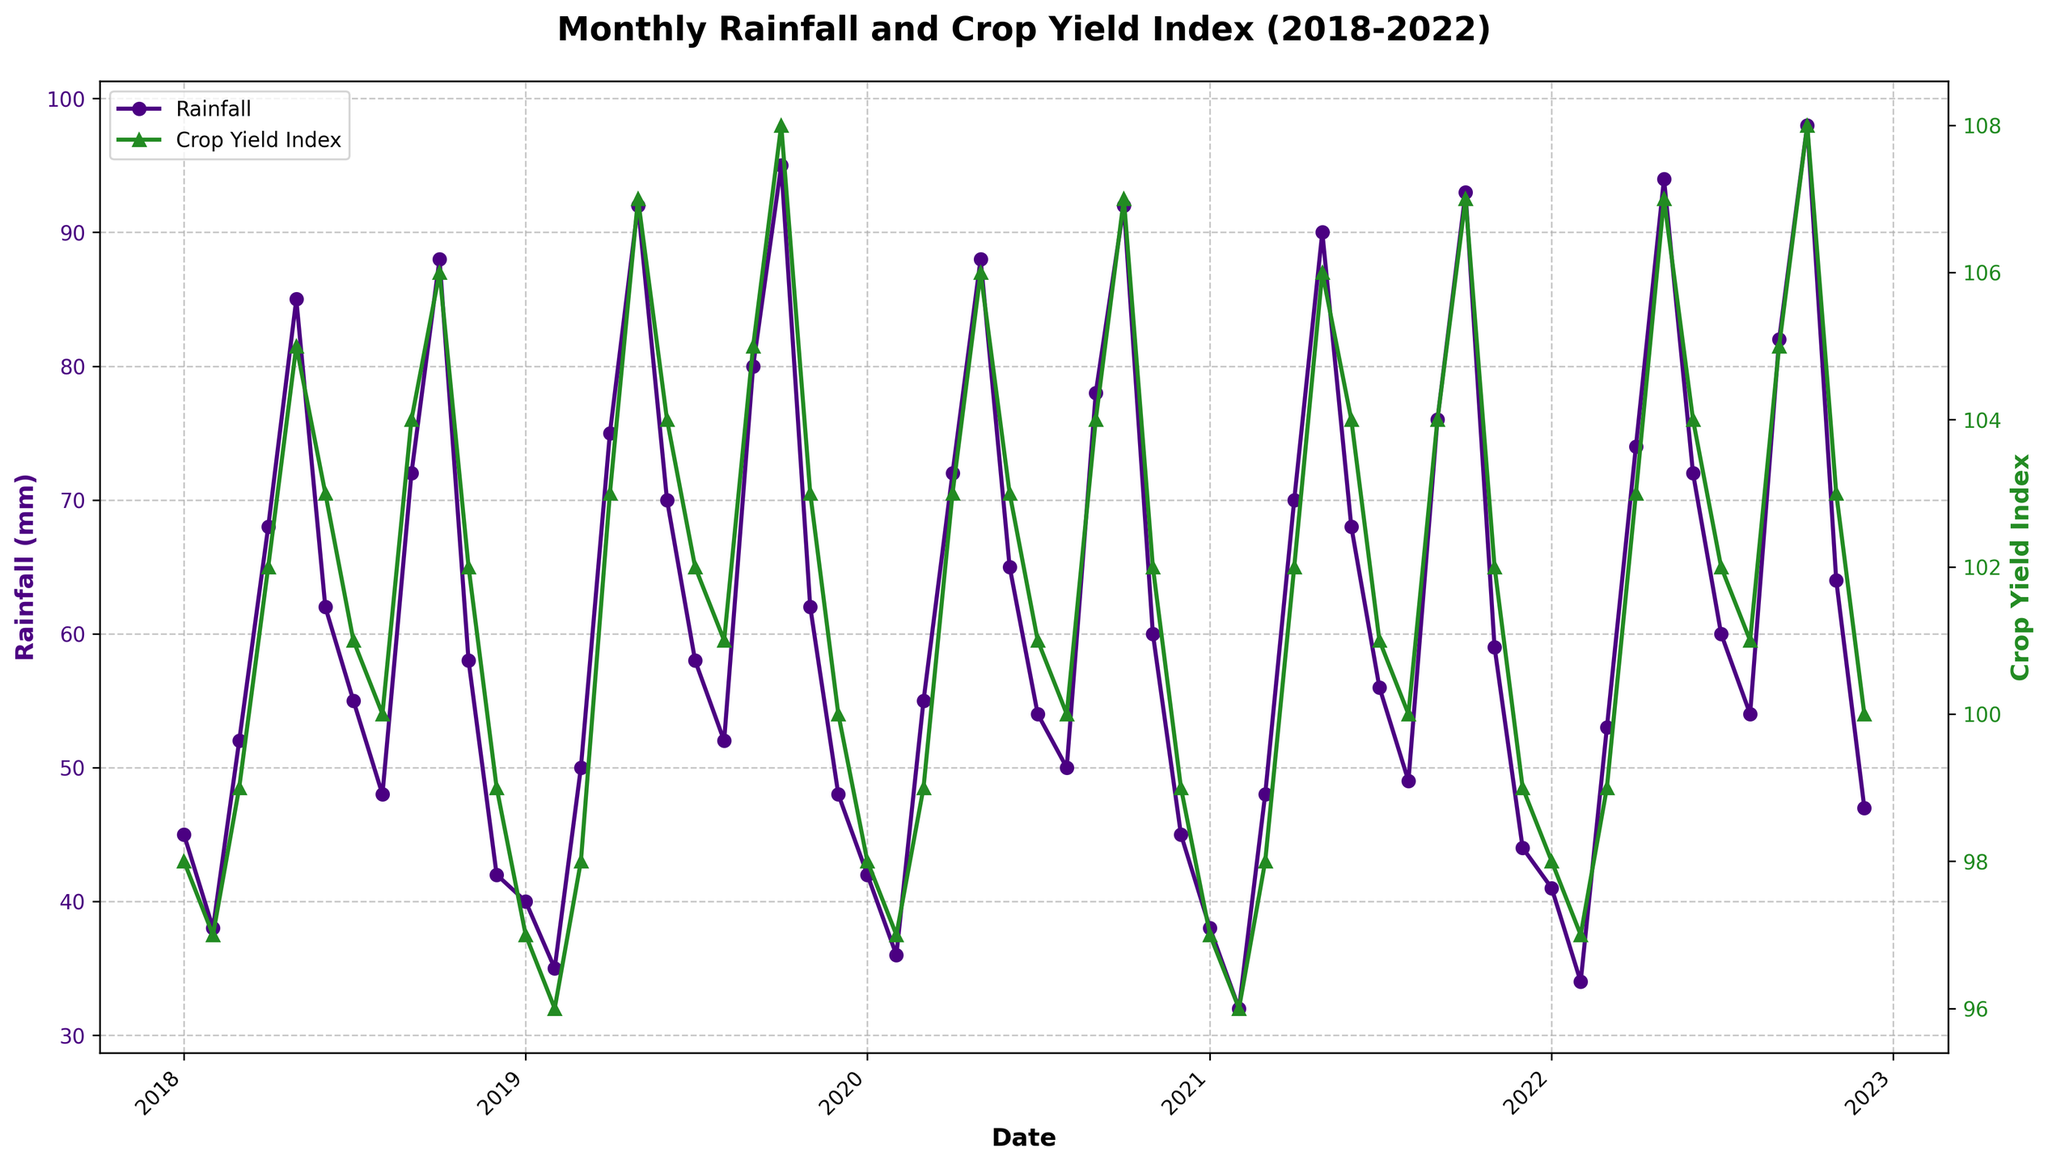What was the total rainfall in 2018? To find the total rainfall in 2018, add up the monthly rainfall values for each month in 2018: 45 + 38 + 52 + 68 + 85 + 62 + 55 + 48 + 72 + 88 + 58 + 42 = 713
Answer: 713 mm Which year had the highest Crop Yield Index in the month of October? Look at the Crop Yield Index values for October in each year and find the highest value: Oct 2018 (106), Oct 2019 (108), Oct 2020 (107), Oct 2021 (107), Oct 2022 (108). The highest value occurs in both 2019 and 2022.
Answer: 2019 and 2022 Did rainfall generally decrease or increase from January to May between 2018 and 2022? Observe the rainfall trend from January to May for each year. For better understanding, calculate the difference for each year: 
2018: 45 to 85 (increase), 
2019: 40 to 92 (increase), 
2020: 42 to 88 (increase), 
2021: 38 to 90 (increase), 
2022: 41 to 94 (increase). It generally increased.
Answer: Increase Between which two consecutive months was the largest increase in Crop Yield Index observed? By examining the Crop Yield Index values month over month for the entire period, identify the largest increase. This occurred from October to November 2018, where the value jumped from 100 to 104.
Answer: October to November 2018 What was the average rainfall in the year with the lowest total rainfall between 2018 and 2022? First, calculate the total rainfall for each year:
2018: 713 mm,
2019: 717 mm, 
2020: 687 mm, 
2021: 731 mm, 
2022: 738 mm.
The lowest total rainfall was in 2020. To find the average, divide the yearly total by 12: 687 mm / 12 = 57.25 mm.
Answer: 57.25 mm How did the Crop Yield Index change from June to July in 2021? Look at the Crop Yield Index values for June and July 2021, which are 104 and 101 respectively. The index decreased by 3 points.
Answer: Decrease by 3 points Which month had the lowest rainfall in 2022? Identify the month in 2022 with the smallest rainfall value: January (41 mm), February (34 mm), April (74 mm), etc. The lowest is February with 34 mm.
Answer: February How does the Crop Yield Index compare between May 2019 and May 2020? The Crop Yield Index in May 2019 was 107, and in May 2020 it was 106. Therefore, the index was 1 point higher in May 2019.
Answer: May 2019 was 1 point higher 